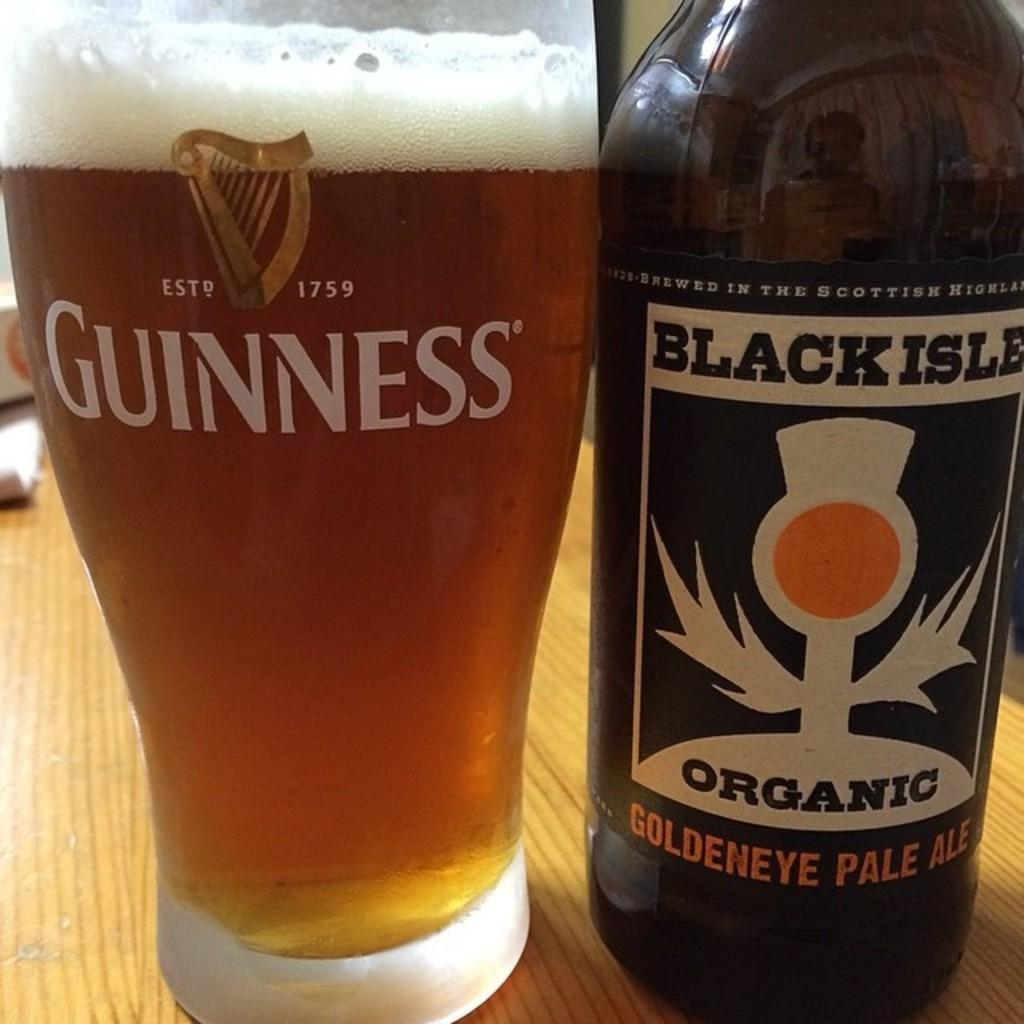<image>
Create a compact narrative representing the image presented. A bottle of Black isle beer has been poured into a guinness glass 